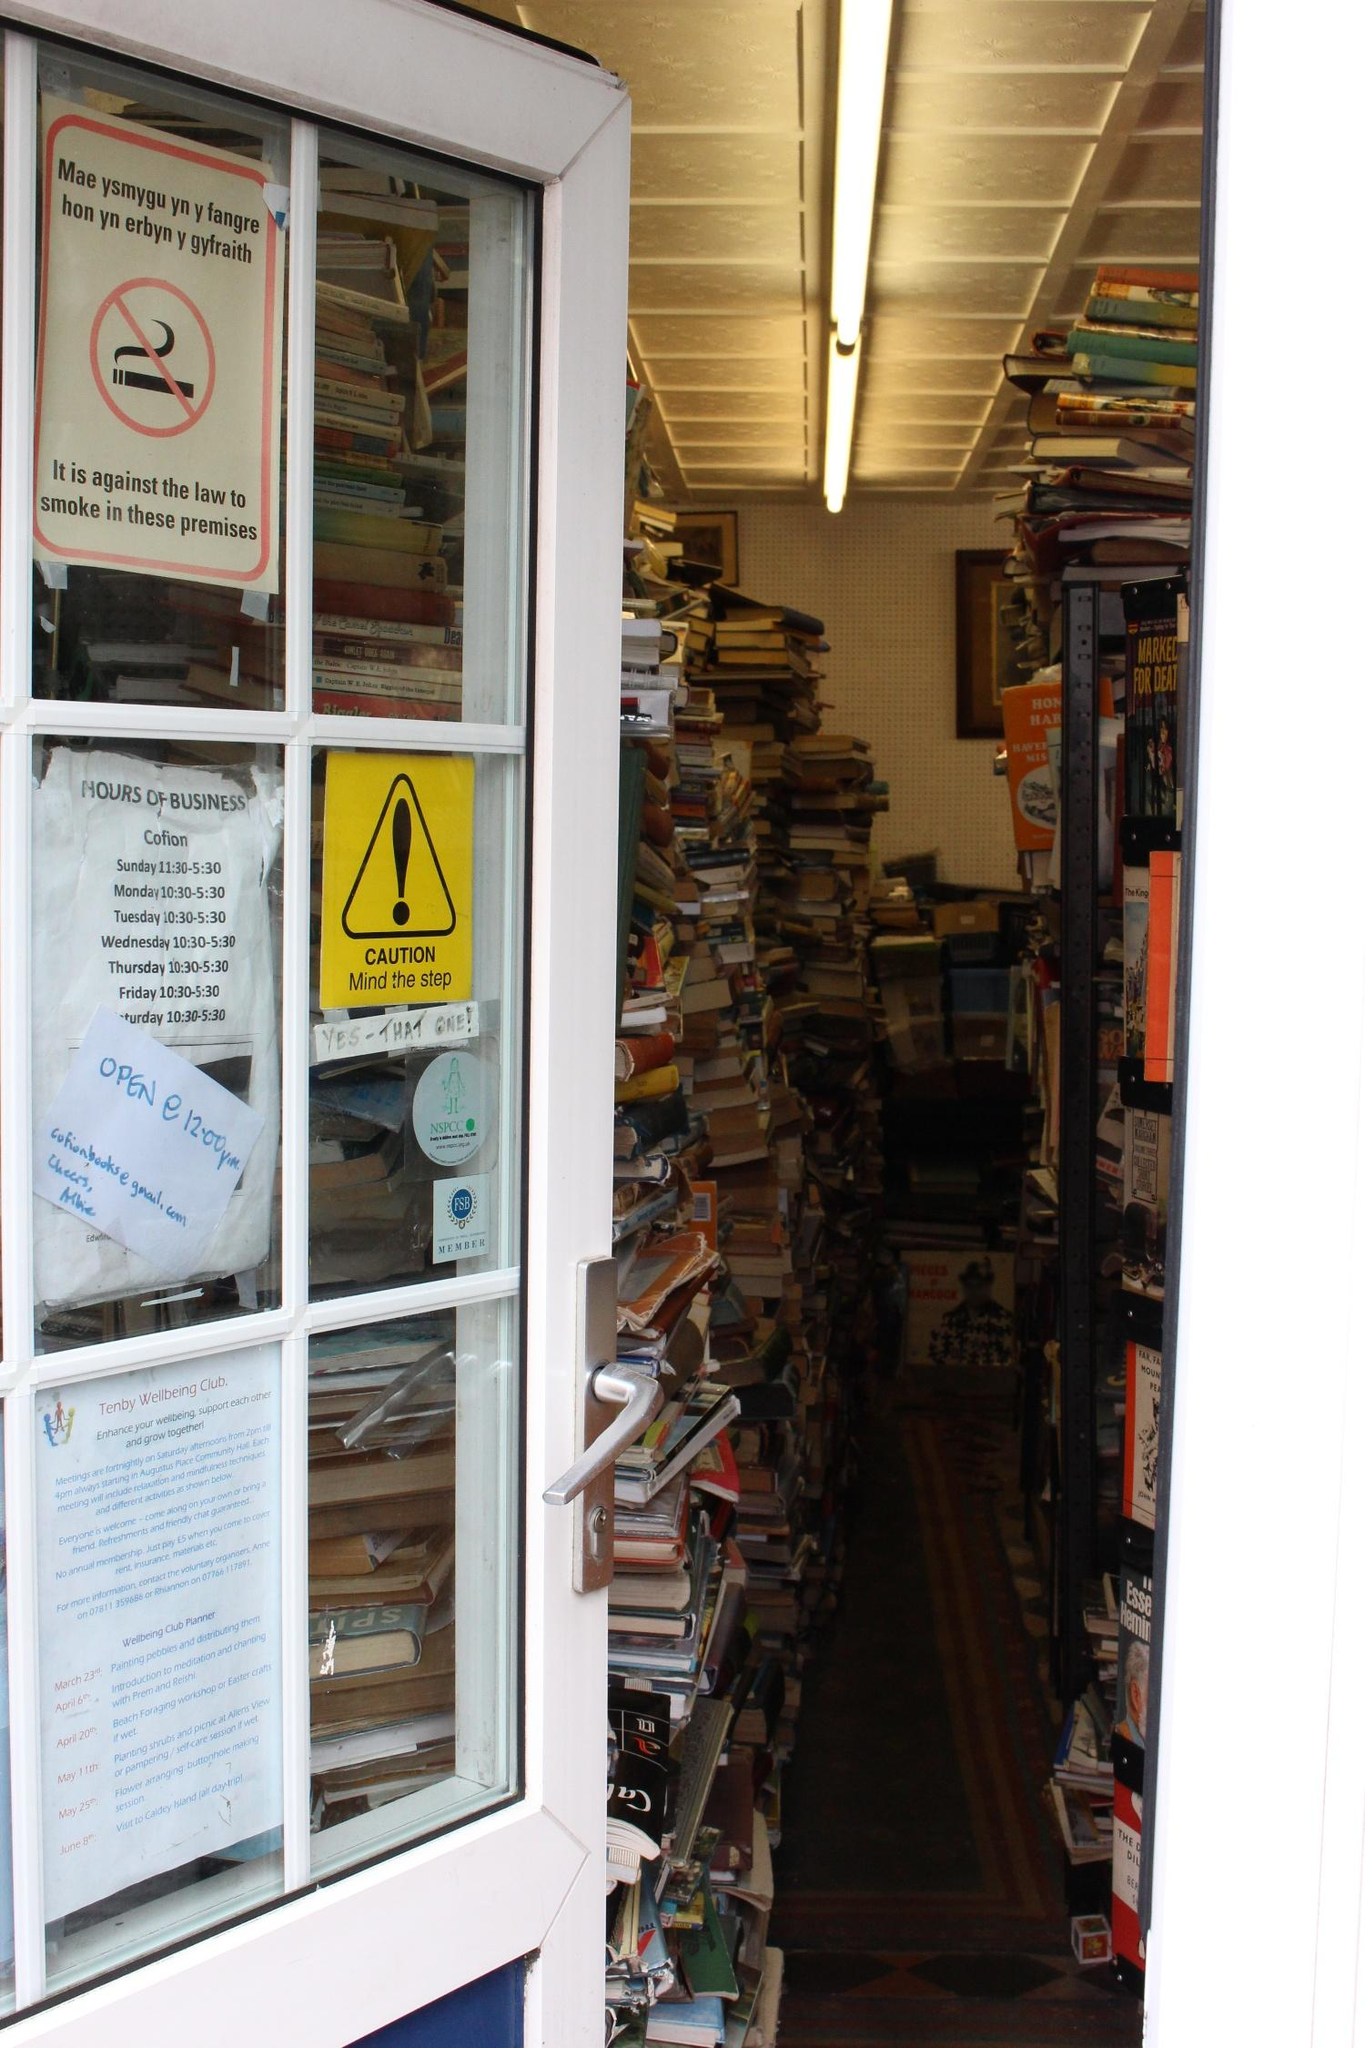What does the reflection on the window suggest about the bookstore's location? The reflection on the window reveals a street scene, suggesting the bookstore is located in an urban or town setting. The presence of buildings and what appears to be a pedestrian walking by indicates it is situated on a street frequented by foot traffic. This can imply that the bookstore benefits from being in a location where passersby might spontaneously decide to visit, thus attracting a range of customers, from locals to tourists exploring the area. 